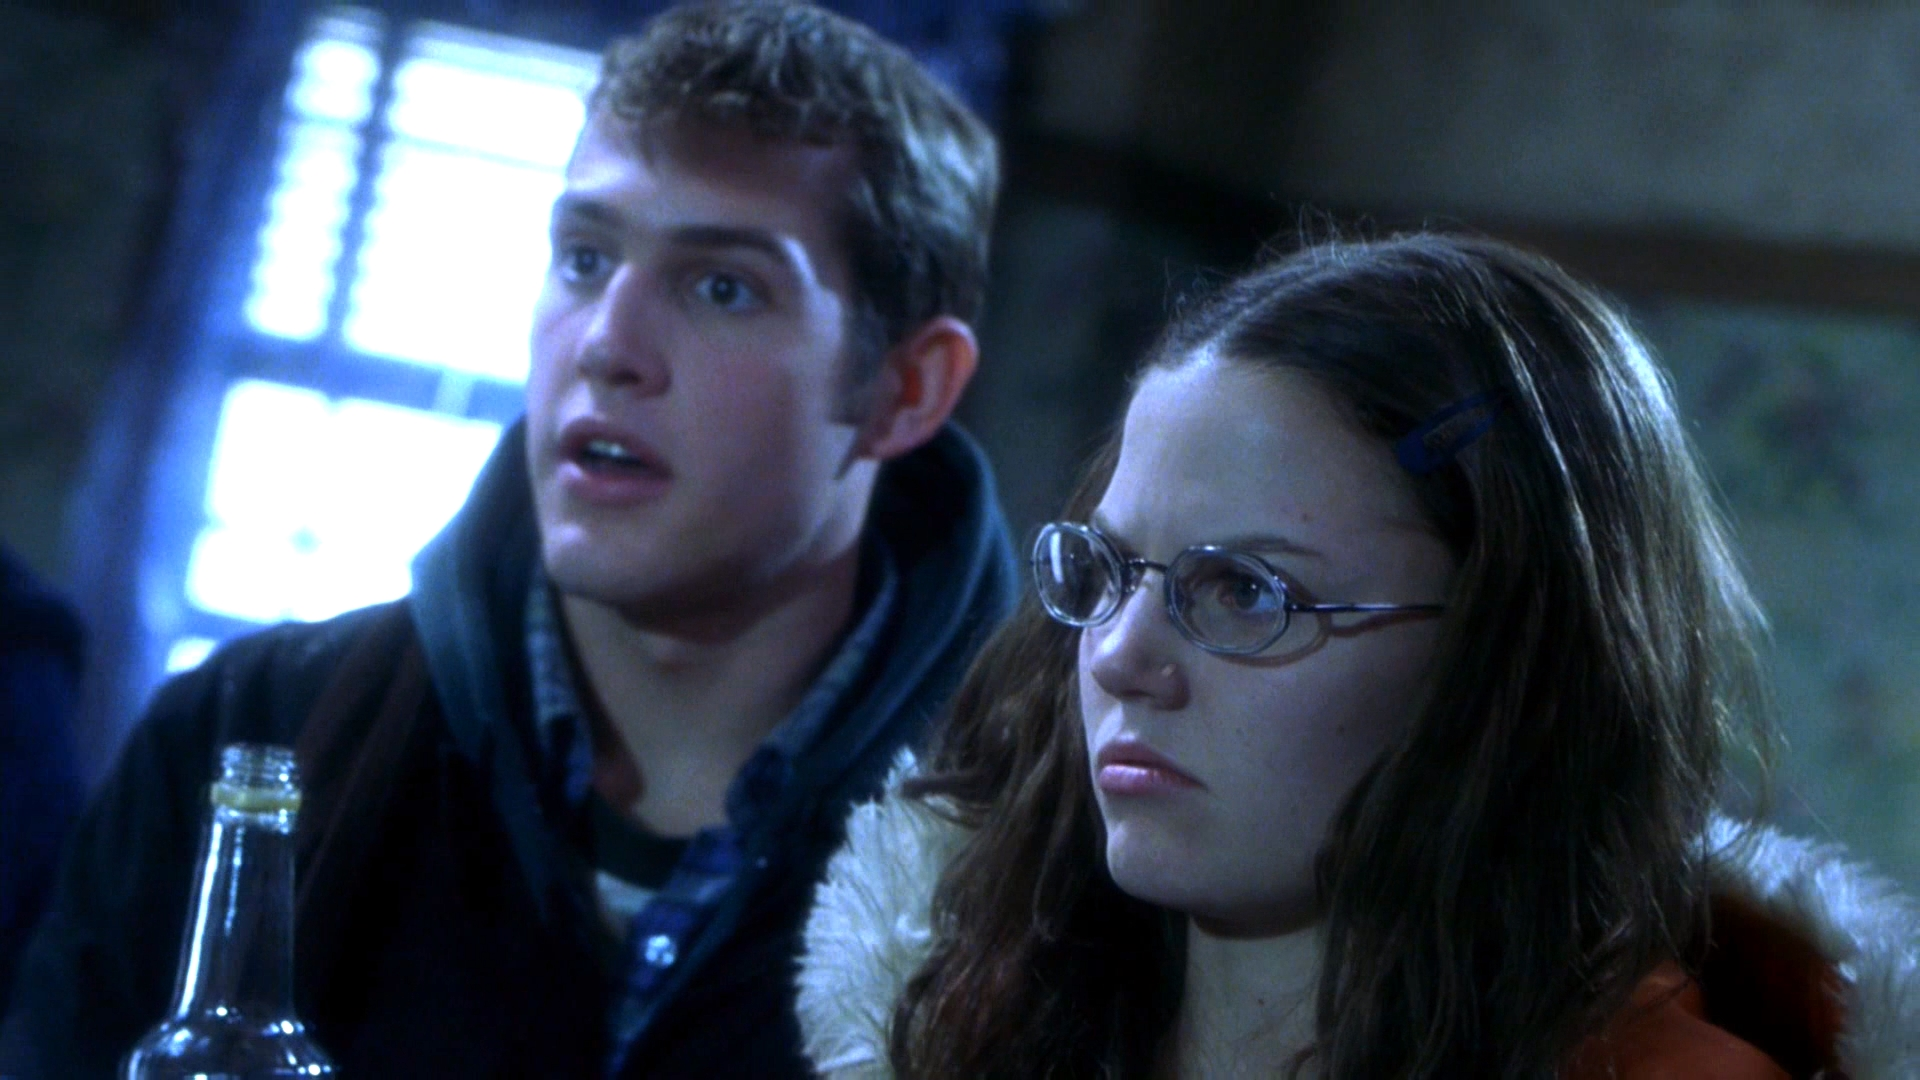What might be the relationship between these two characters based on their attire and interaction? Their coordinated, somewhat casual yet practical attire, along with their cohesive reactions, suggests a close working relationship. Possibly colleagues or team members, they seem to be involved jointly in their tasks or goals within a professional setting, indicating a mutual reliance or partnership. 